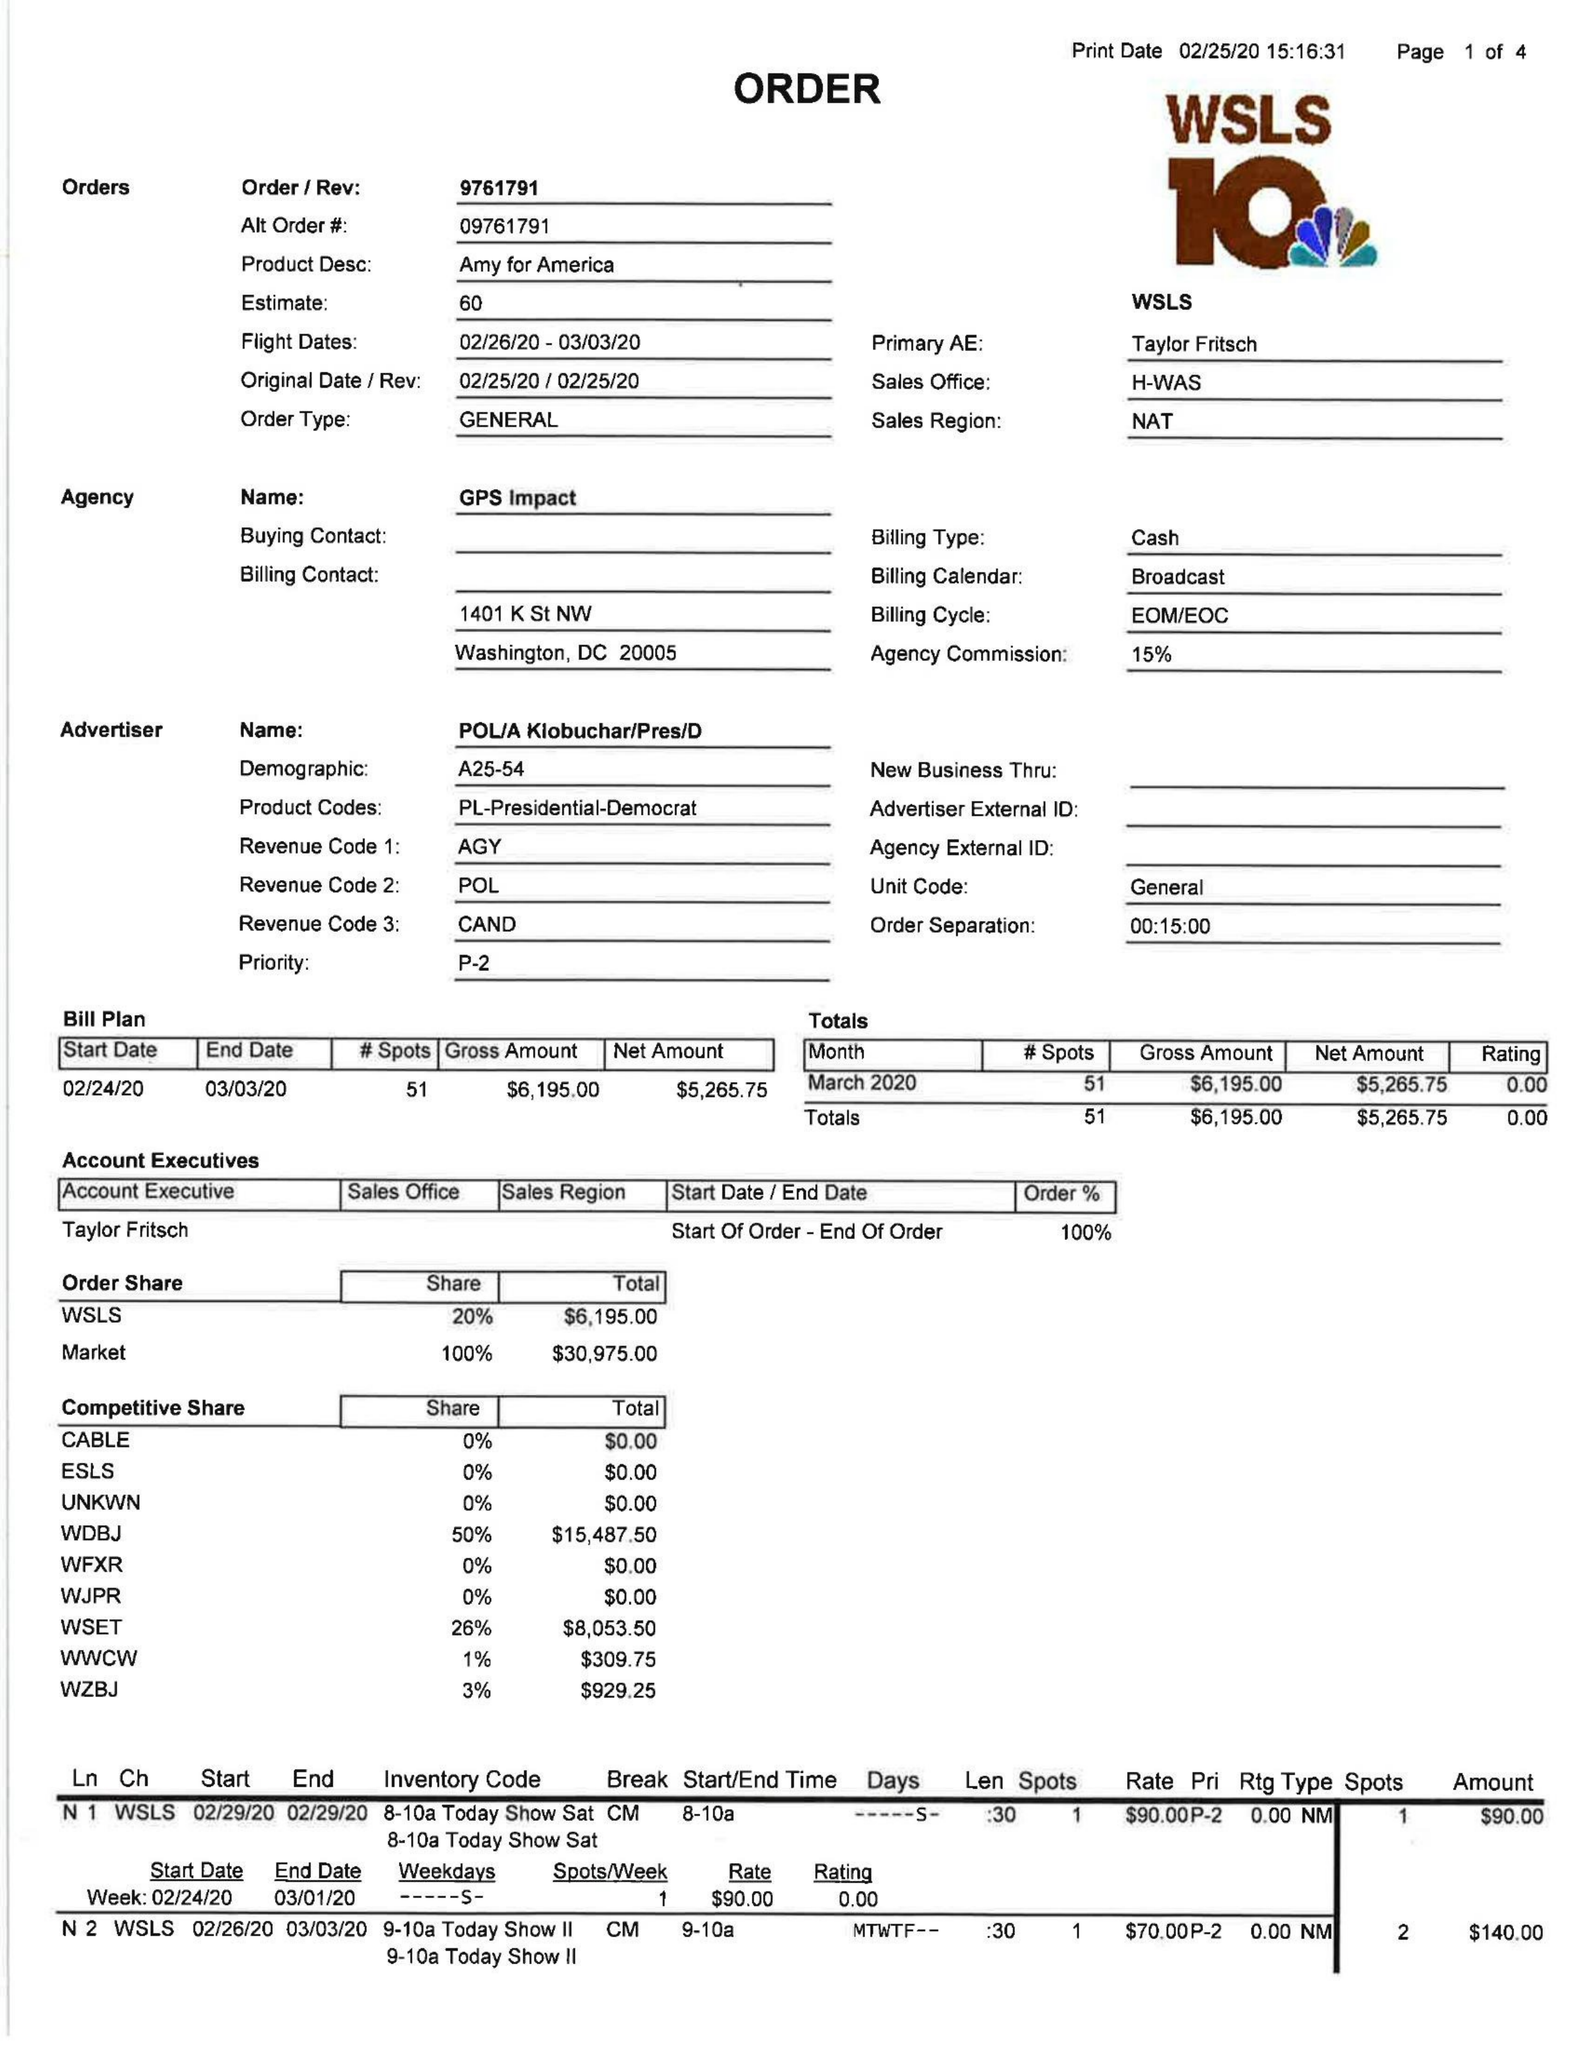What is the value for the gross_amount?
Answer the question using a single word or phrase. 6195.00 